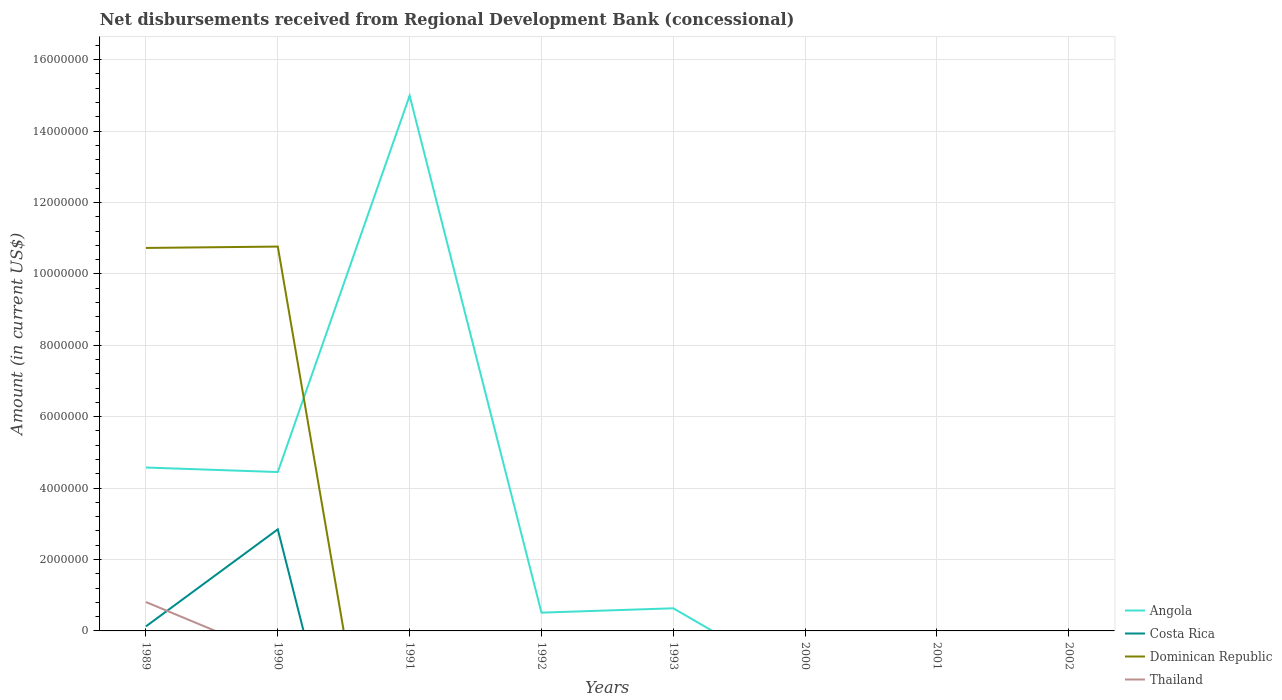How many different coloured lines are there?
Make the answer very short. 4. Does the line corresponding to Costa Rica intersect with the line corresponding to Angola?
Make the answer very short. No. Is the number of lines equal to the number of legend labels?
Your answer should be compact. No. What is the total amount of disbursements received from Regional Development Bank in Dominican Republic in the graph?
Give a very brief answer. -3.80e+04. What is the difference between the highest and the second highest amount of disbursements received from Regional Development Bank in Costa Rica?
Offer a very short reply. 2.84e+06. What is the difference between the highest and the lowest amount of disbursements received from Regional Development Bank in Angola?
Make the answer very short. 3. Is the amount of disbursements received from Regional Development Bank in Thailand strictly greater than the amount of disbursements received from Regional Development Bank in Costa Rica over the years?
Your response must be concise. No. How many lines are there?
Make the answer very short. 4. Where does the legend appear in the graph?
Offer a very short reply. Bottom right. What is the title of the graph?
Provide a succinct answer. Net disbursements received from Regional Development Bank (concessional). What is the label or title of the X-axis?
Your answer should be compact. Years. What is the label or title of the Y-axis?
Your response must be concise. Amount (in current US$). What is the Amount (in current US$) in Angola in 1989?
Provide a short and direct response. 4.58e+06. What is the Amount (in current US$) in Costa Rica in 1989?
Ensure brevity in your answer.  1.27e+05. What is the Amount (in current US$) in Dominican Republic in 1989?
Your answer should be compact. 1.07e+07. What is the Amount (in current US$) in Thailand in 1989?
Your answer should be very brief. 8.09e+05. What is the Amount (in current US$) in Angola in 1990?
Your response must be concise. 4.45e+06. What is the Amount (in current US$) in Costa Rica in 1990?
Ensure brevity in your answer.  2.84e+06. What is the Amount (in current US$) in Dominican Republic in 1990?
Ensure brevity in your answer.  1.08e+07. What is the Amount (in current US$) in Thailand in 1990?
Your answer should be compact. 0. What is the Amount (in current US$) of Angola in 1991?
Ensure brevity in your answer.  1.50e+07. What is the Amount (in current US$) in Thailand in 1991?
Offer a terse response. 0. What is the Amount (in current US$) of Angola in 1992?
Your answer should be compact. 5.12e+05. What is the Amount (in current US$) of Costa Rica in 1992?
Keep it short and to the point. 0. What is the Amount (in current US$) of Dominican Republic in 1992?
Your response must be concise. 0. What is the Amount (in current US$) in Angola in 1993?
Give a very brief answer. 6.34e+05. What is the Amount (in current US$) of Costa Rica in 1993?
Make the answer very short. 0. What is the Amount (in current US$) in Dominican Republic in 1993?
Your response must be concise. 0. What is the Amount (in current US$) in Thailand in 1993?
Give a very brief answer. 0. What is the Amount (in current US$) in Costa Rica in 2001?
Ensure brevity in your answer.  0. What is the Amount (in current US$) in Dominican Republic in 2001?
Keep it short and to the point. 0. Across all years, what is the maximum Amount (in current US$) of Angola?
Keep it short and to the point. 1.50e+07. Across all years, what is the maximum Amount (in current US$) of Costa Rica?
Give a very brief answer. 2.84e+06. Across all years, what is the maximum Amount (in current US$) of Dominican Republic?
Keep it short and to the point. 1.08e+07. Across all years, what is the maximum Amount (in current US$) in Thailand?
Offer a very short reply. 8.09e+05. Across all years, what is the minimum Amount (in current US$) of Dominican Republic?
Your response must be concise. 0. Across all years, what is the minimum Amount (in current US$) in Thailand?
Your answer should be very brief. 0. What is the total Amount (in current US$) in Angola in the graph?
Provide a short and direct response. 2.52e+07. What is the total Amount (in current US$) of Costa Rica in the graph?
Your answer should be very brief. 2.97e+06. What is the total Amount (in current US$) of Dominican Republic in the graph?
Provide a short and direct response. 2.15e+07. What is the total Amount (in current US$) of Thailand in the graph?
Provide a succinct answer. 8.09e+05. What is the difference between the Amount (in current US$) of Angola in 1989 and that in 1990?
Provide a short and direct response. 1.27e+05. What is the difference between the Amount (in current US$) of Costa Rica in 1989 and that in 1990?
Ensure brevity in your answer.  -2.72e+06. What is the difference between the Amount (in current US$) of Dominican Republic in 1989 and that in 1990?
Offer a very short reply. -3.80e+04. What is the difference between the Amount (in current US$) in Angola in 1989 and that in 1991?
Ensure brevity in your answer.  -1.04e+07. What is the difference between the Amount (in current US$) of Angola in 1989 and that in 1992?
Ensure brevity in your answer.  4.06e+06. What is the difference between the Amount (in current US$) of Angola in 1989 and that in 1993?
Your response must be concise. 3.94e+06. What is the difference between the Amount (in current US$) of Angola in 1990 and that in 1991?
Provide a succinct answer. -1.05e+07. What is the difference between the Amount (in current US$) in Angola in 1990 and that in 1992?
Keep it short and to the point. 3.94e+06. What is the difference between the Amount (in current US$) of Angola in 1990 and that in 1993?
Your answer should be very brief. 3.82e+06. What is the difference between the Amount (in current US$) in Angola in 1991 and that in 1992?
Make the answer very short. 1.45e+07. What is the difference between the Amount (in current US$) of Angola in 1991 and that in 1993?
Provide a succinct answer. 1.44e+07. What is the difference between the Amount (in current US$) in Angola in 1992 and that in 1993?
Ensure brevity in your answer.  -1.22e+05. What is the difference between the Amount (in current US$) of Angola in 1989 and the Amount (in current US$) of Costa Rica in 1990?
Give a very brief answer. 1.73e+06. What is the difference between the Amount (in current US$) in Angola in 1989 and the Amount (in current US$) in Dominican Republic in 1990?
Offer a very short reply. -6.19e+06. What is the difference between the Amount (in current US$) of Costa Rica in 1989 and the Amount (in current US$) of Dominican Republic in 1990?
Offer a terse response. -1.06e+07. What is the average Amount (in current US$) in Angola per year?
Give a very brief answer. 3.15e+06. What is the average Amount (in current US$) in Costa Rica per year?
Your answer should be compact. 3.72e+05. What is the average Amount (in current US$) of Dominican Republic per year?
Keep it short and to the point. 2.69e+06. What is the average Amount (in current US$) of Thailand per year?
Your answer should be very brief. 1.01e+05. In the year 1989, what is the difference between the Amount (in current US$) of Angola and Amount (in current US$) of Costa Rica?
Provide a short and direct response. 4.45e+06. In the year 1989, what is the difference between the Amount (in current US$) of Angola and Amount (in current US$) of Dominican Republic?
Your answer should be compact. -6.15e+06. In the year 1989, what is the difference between the Amount (in current US$) of Angola and Amount (in current US$) of Thailand?
Your response must be concise. 3.77e+06. In the year 1989, what is the difference between the Amount (in current US$) in Costa Rica and Amount (in current US$) in Dominican Republic?
Your response must be concise. -1.06e+07. In the year 1989, what is the difference between the Amount (in current US$) of Costa Rica and Amount (in current US$) of Thailand?
Ensure brevity in your answer.  -6.82e+05. In the year 1989, what is the difference between the Amount (in current US$) in Dominican Republic and Amount (in current US$) in Thailand?
Give a very brief answer. 9.92e+06. In the year 1990, what is the difference between the Amount (in current US$) in Angola and Amount (in current US$) in Costa Rica?
Offer a terse response. 1.60e+06. In the year 1990, what is the difference between the Amount (in current US$) in Angola and Amount (in current US$) in Dominican Republic?
Your response must be concise. -6.32e+06. In the year 1990, what is the difference between the Amount (in current US$) in Costa Rica and Amount (in current US$) in Dominican Republic?
Ensure brevity in your answer.  -7.92e+06. What is the ratio of the Amount (in current US$) of Angola in 1989 to that in 1990?
Offer a terse response. 1.03. What is the ratio of the Amount (in current US$) in Costa Rica in 1989 to that in 1990?
Keep it short and to the point. 0.04. What is the ratio of the Amount (in current US$) of Dominican Republic in 1989 to that in 1990?
Provide a short and direct response. 1. What is the ratio of the Amount (in current US$) in Angola in 1989 to that in 1991?
Make the answer very short. 0.31. What is the ratio of the Amount (in current US$) in Angola in 1989 to that in 1992?
Offer a terse response. 8.94. What is the ratio of the Amount (in current US$) of Angola in 1989 to that in 1993?
Ensure brevity in your answer.  7.22. What is the ratio of the Amount (in current US$) in Angola in 1990 to that in 1991?
Provide a succinct answer. 0.3. What is the ratio of the Amount (in current US$) of Angola in 1990 to that in 1992?
Provide a succinct answer. 8.69. What is the ratio of the Amount (in current US$) in Angola in 1990 to that in 1993?
Provide a succinct answer. 7.02. What is the ratio of the Amount (in current US$) in Angola in 1991 to that in 1992?
Provide a succinct answer. 29.28. What is the ratio of the Amount (in current US$) in Angola in 1991 to that in 1993?
Your answer should be compact. 23.65. What is the ratio of the Amount (in current US$) of Angola in 1992 to that in 1993?
Your response must be concise. 0.81. What is the difference between the highest and the second highest Amount (in current US$) of Angola?
Offer a very short reply. 1.04e+07. What is the difference between the highest and the lowest Amount (in current US$) of Angola?
Your answer should be compact. 1.50e+07. What is the difference between the highest and the lowest Amount (in current US$) of Costa Rica?
Offer a terse response. 2.84e+06. What is the difference between the highest and the lowest Amount (in current US$) of Dominican Republic?
Provide a short and direct response. 1.08e+07. What is the difference between the highest and the lowest Amount (in current US$) in Thailand?
Offer a terse response. 8.09e+05. 